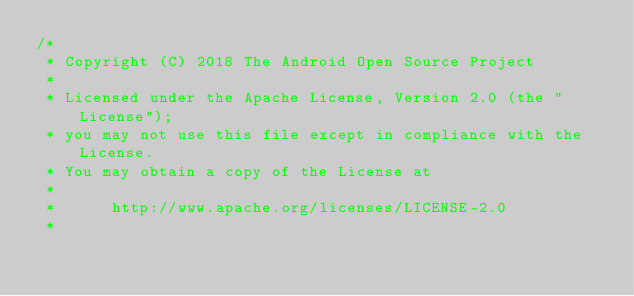<code> <loc_0><loc_0><loc_500><loc_500><_Java_>/*
 * Copyright (C) 2018 The Android Open Source Project
 *
 * Licensed under the Apache License, Version 2.0 (the "License");
 * you may not use this file except in compliance with the License.
 * You may obtain a copy of the License at
 *
 *      http://www.apache.org/licenses/LICENSE-2.0
 *</code> 